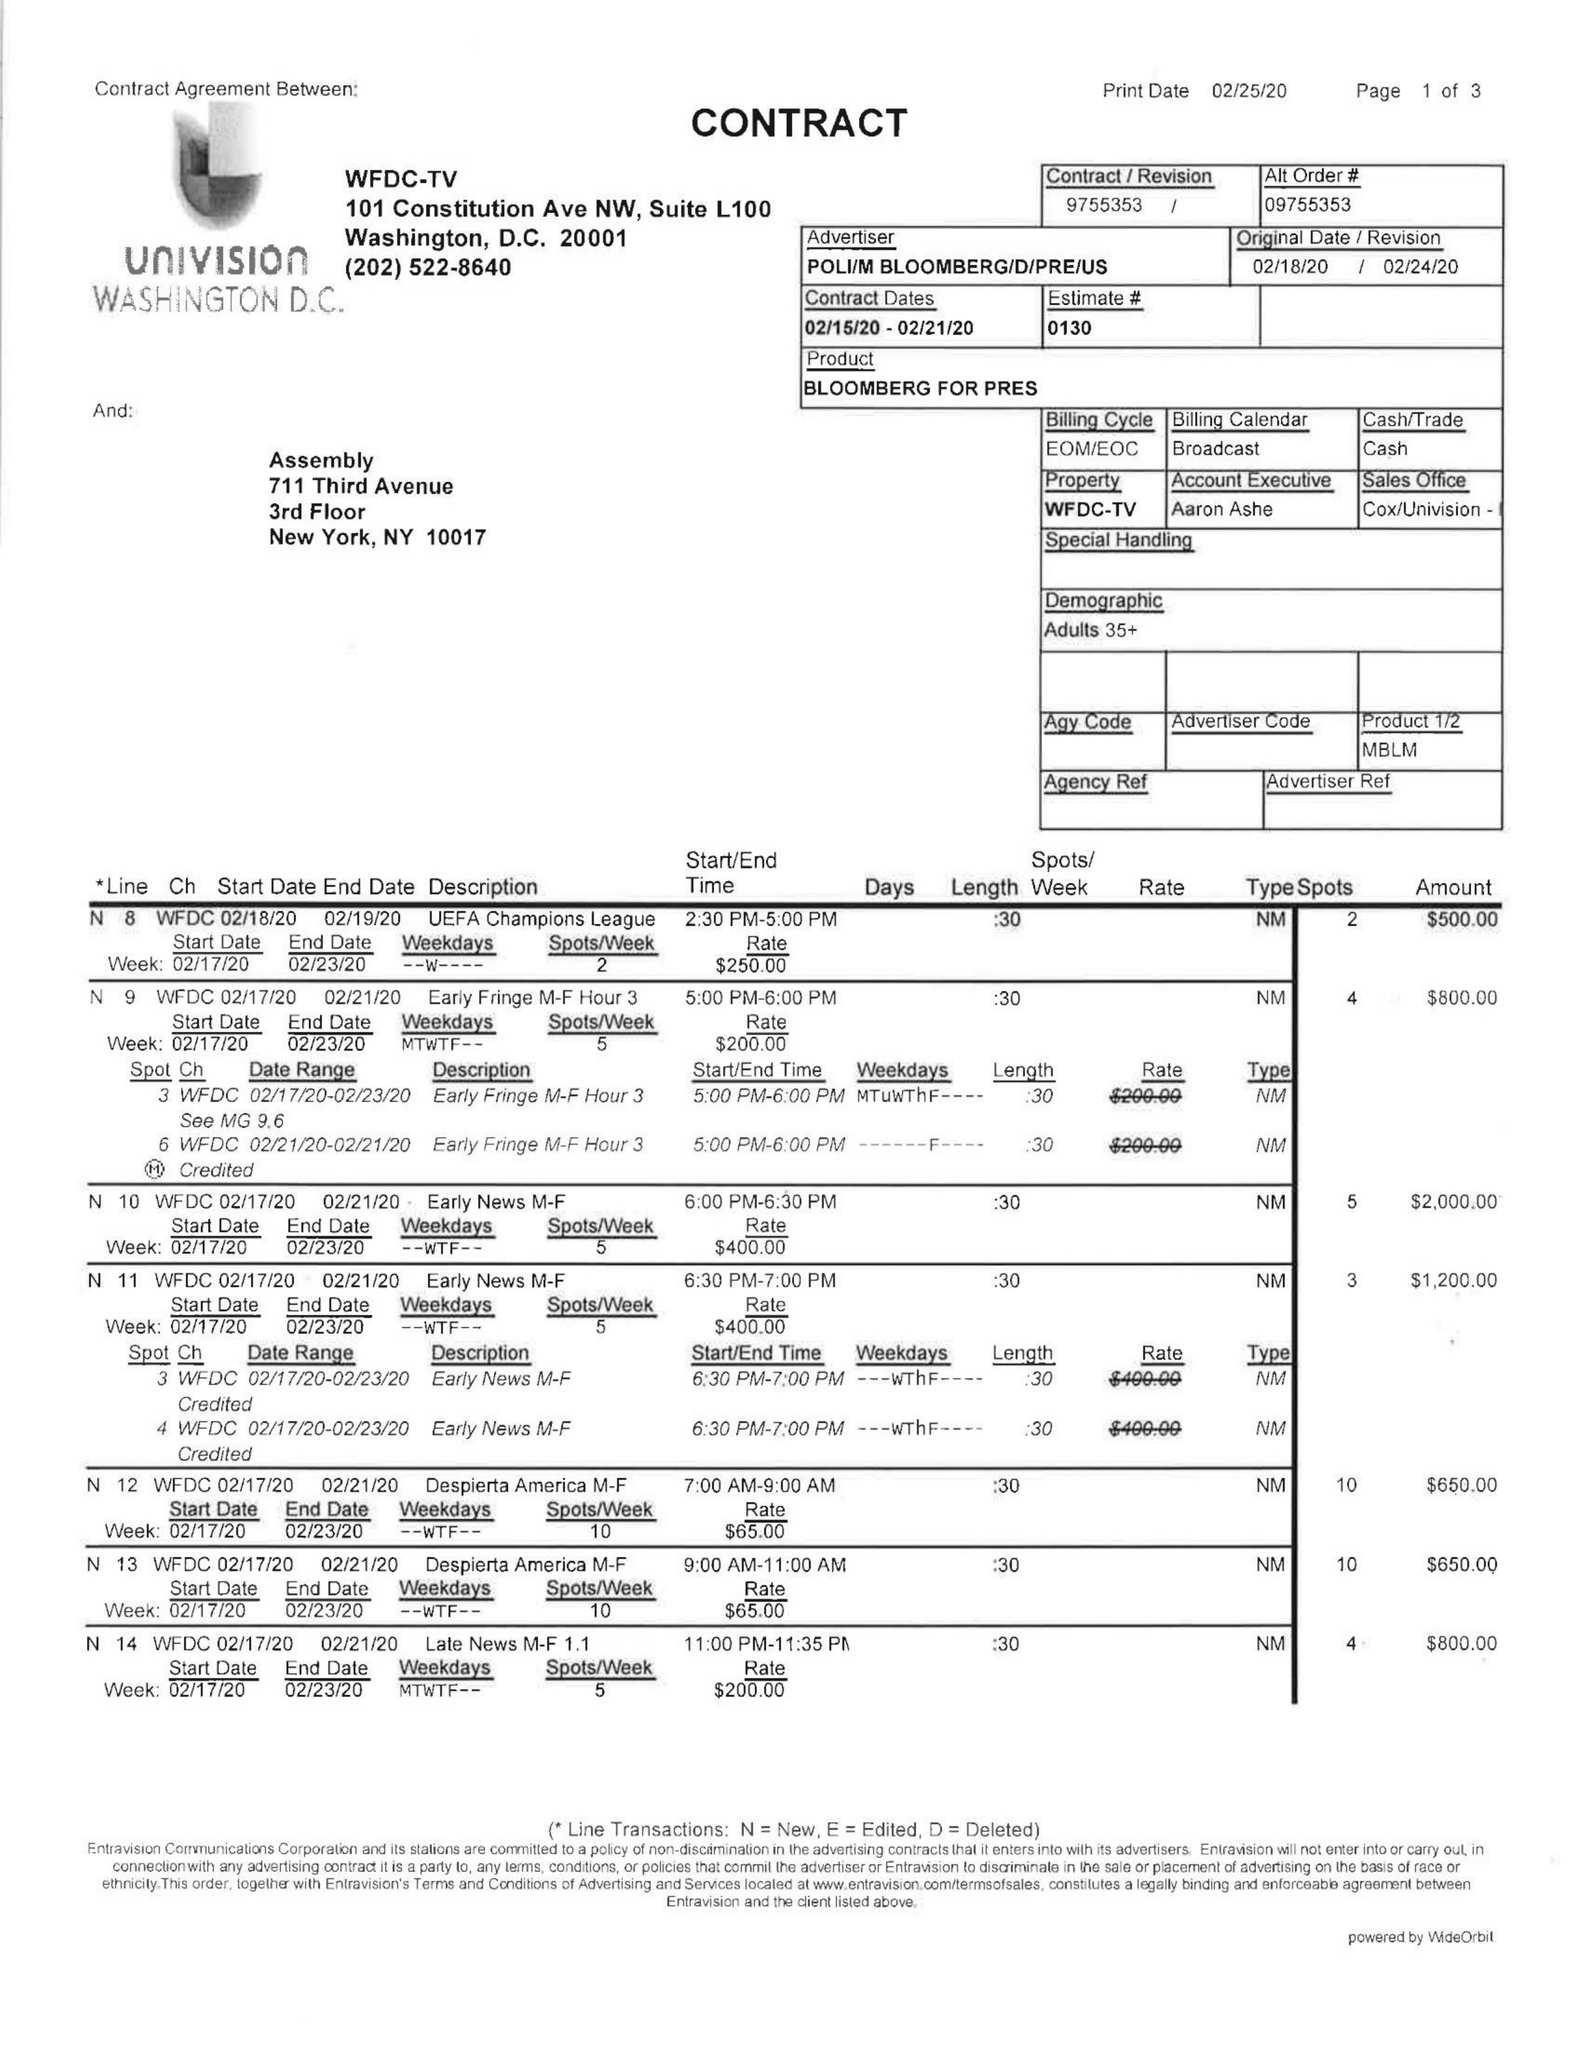What is the value for the gross_amount?
Answer the question using a single word or phrase. 9135.00 